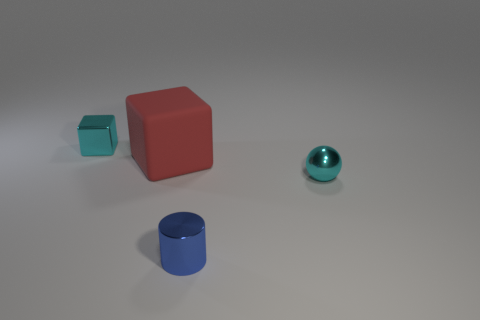Add 4 tiny gray objects. How many objects exist? 8 Subtract all balls. How many objects are left? 3 Add 4 tiny metal balls. How many tiny metal balls are left? 5 Add 1 rubber spheres. How many rubber spheres exist? 1 Subtract 0 yellow cylinders. How many objects are left? 4 Subtract all red blocks. Subtract all brown metallic spheres. How many objects are left? 3 